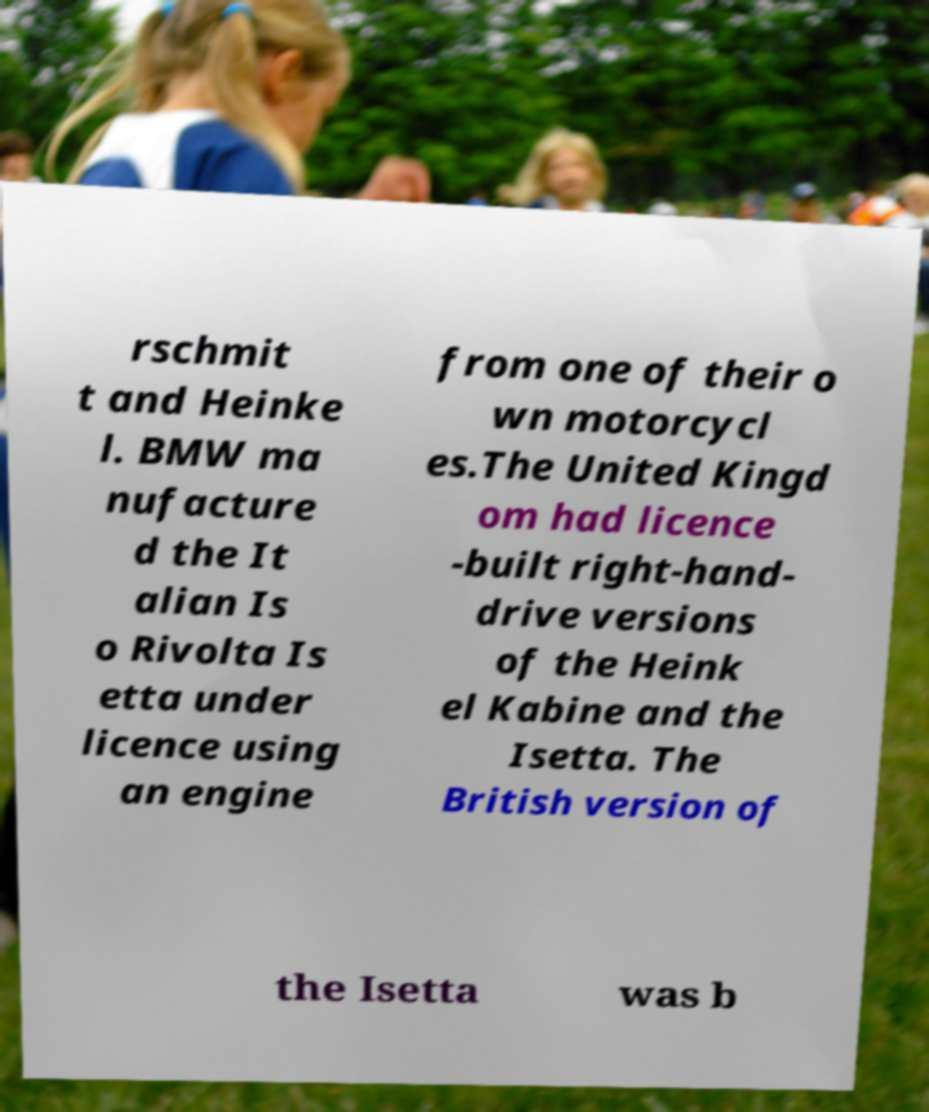Can you accurately transcribe the text from the provided image for me? rschmit t and Heinke l. BMW ma nufacture d the It alian Is o Rivolta Is etta under licence using an engine from one of their o wn motorcycl es.The United Kingd om had licence -built right-hand- drive versions of the Heink el Kabine and the Isetta. The British version of the Isetta was b 